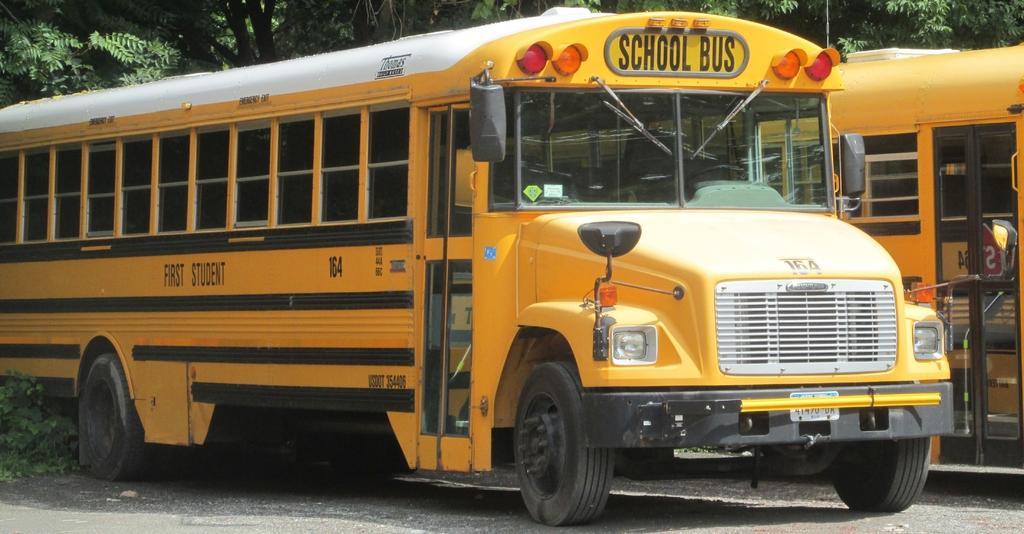Can you describe this image briefly? In this image we can see two yellow color school bus. Background of the image trees are there. 